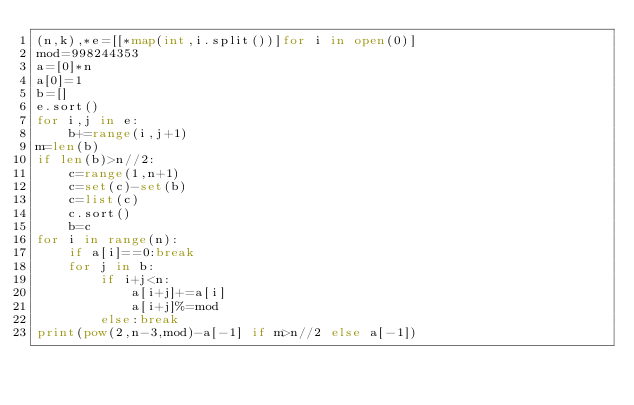<code> <loc_0><loc_0><loc_500><loc_500><_Python_>(n,k),*e=[[*map(int,i.split())]for i in open(0)]
mod=998244353
a=[0]*n
a[0]=1
b=[]
e.sort()
for i,j in e:
    b+=range(i,j+1)
m=len(b)
if len(b)>n//2:
    c=range(1,n+1)
    c=set(c)-set(b)
    c=list(c)
    c.sort()
    b=c
for i in range(n):
    if a[i]==0:break
    for j in b:
        if i+j<n:
            a[i+j]+=a[i]
            a[i+j]%=mod
        else:break
print(pow(2,n-3,mod)-a[-1] if m>n//2 else a[-1]) </code> 